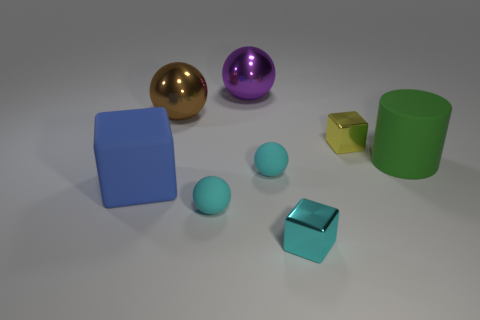Is there a yellow block of the same size as the yellow thing?
Your answer should be very brief. No. There is a tiny matte sphere that is behind the large block; what is its color?
Your answer should be very brief. Cyan. Are there any large blue matte things that are in front of the large rubber thing that is to the right of the big brown metallic ball?
Your response must be concise. Yes. Does the rubber sphere that is behind the matte block have the same size as the shiny object in front of the yellow metallic object?
Make the answer very short. Yes. What size is the shiny cube that is on the right side of the tiny cube in front of the green object?
Your answer should be very brief. Small. What material is the sphere that is in front of the big purple object and behind the tiny yellow block?
Your answer should be very brief. Metal. The matte cube has what color?
Keep it short and to the point. Blue. Is there anything else that is the same material as the yellow thing?
Provide a short and direct response. Yes. There is a big rubber object in front of the large matte cylinder; what is its shape?
Offer a terse response. Cube. There is a large rubber object that is left of the shiny cube that is to the right of the small cyan block; is there a big brown metallic object left of it?
Give a very brief answer. No. 